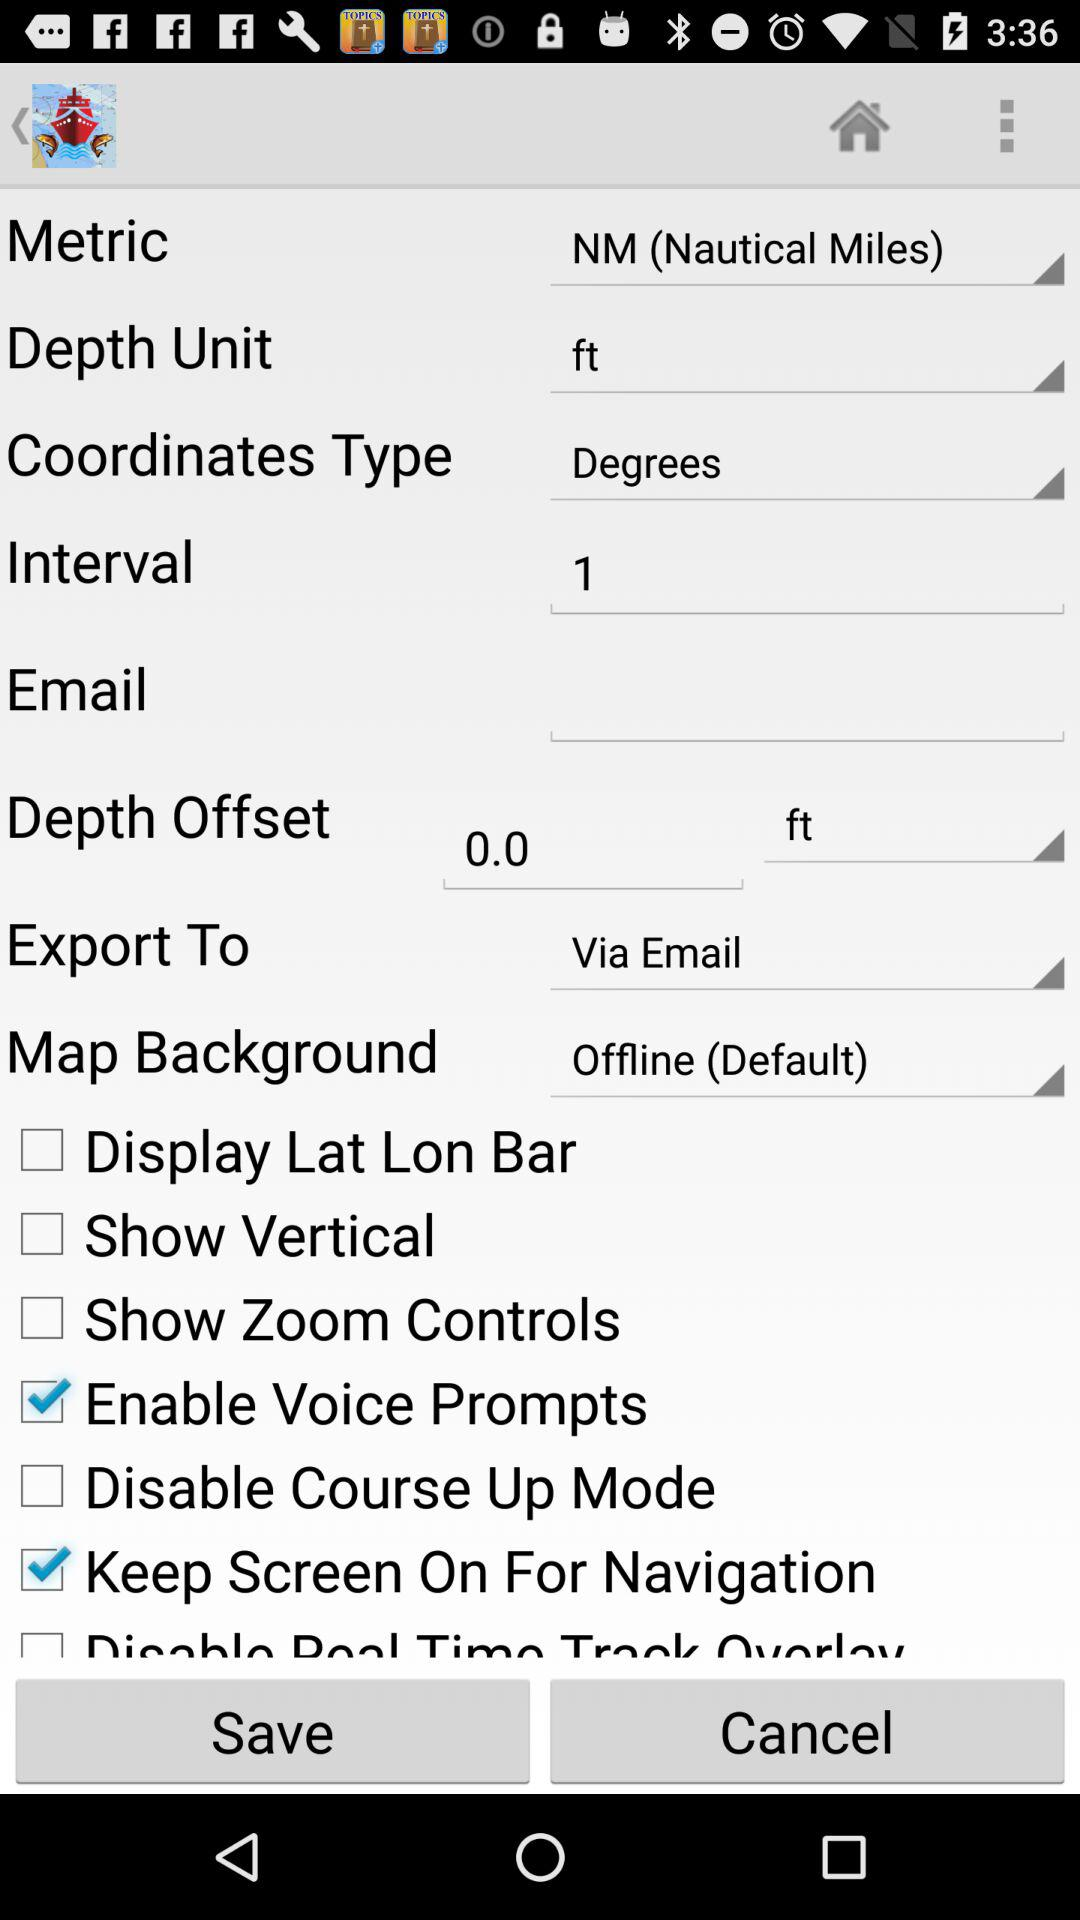What is the depth unit? The depth unit is feet. 